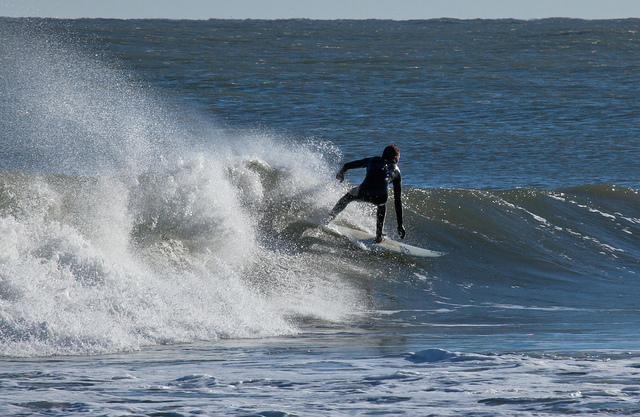How many people are in the water?
Give a very brief answer. 1. 